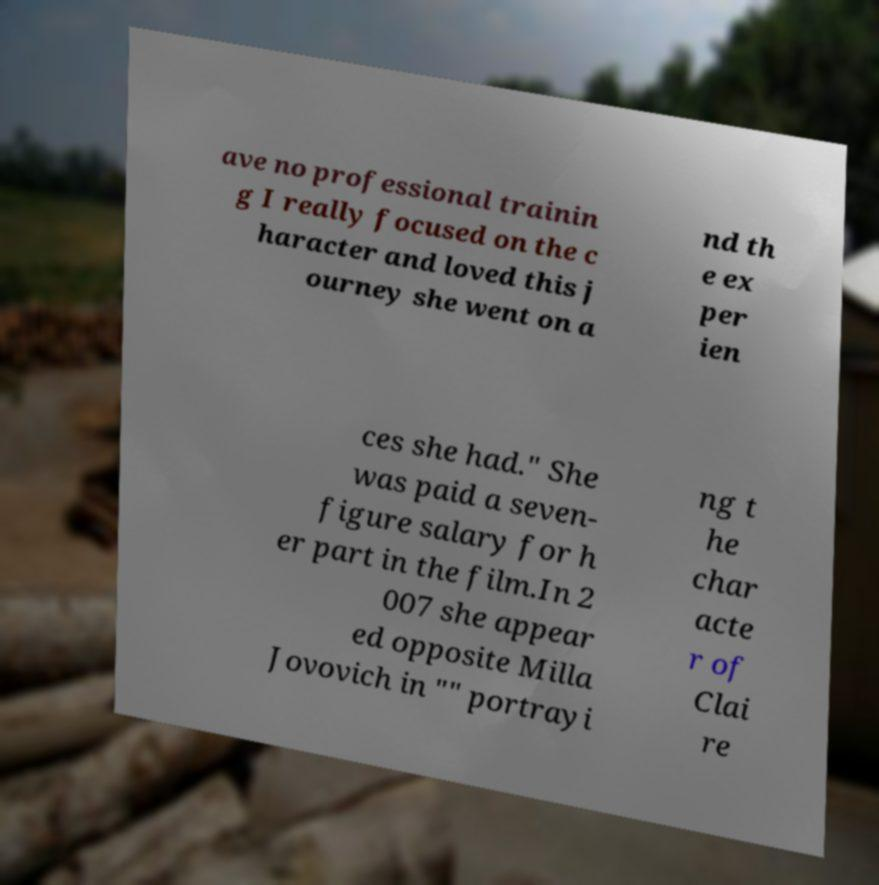I need the written content from this picture converted into text. Can you do that? ave no professional trainin g I really focused on the c haracter and loved this j ourney she went on a nd th e ex per ien ces she had." She was paid a seven- figure salary for h er part in the film.In 2 007 she appear ed opposite Milla Jovovich in "" portrayi ng t he char acte r of Clai re 